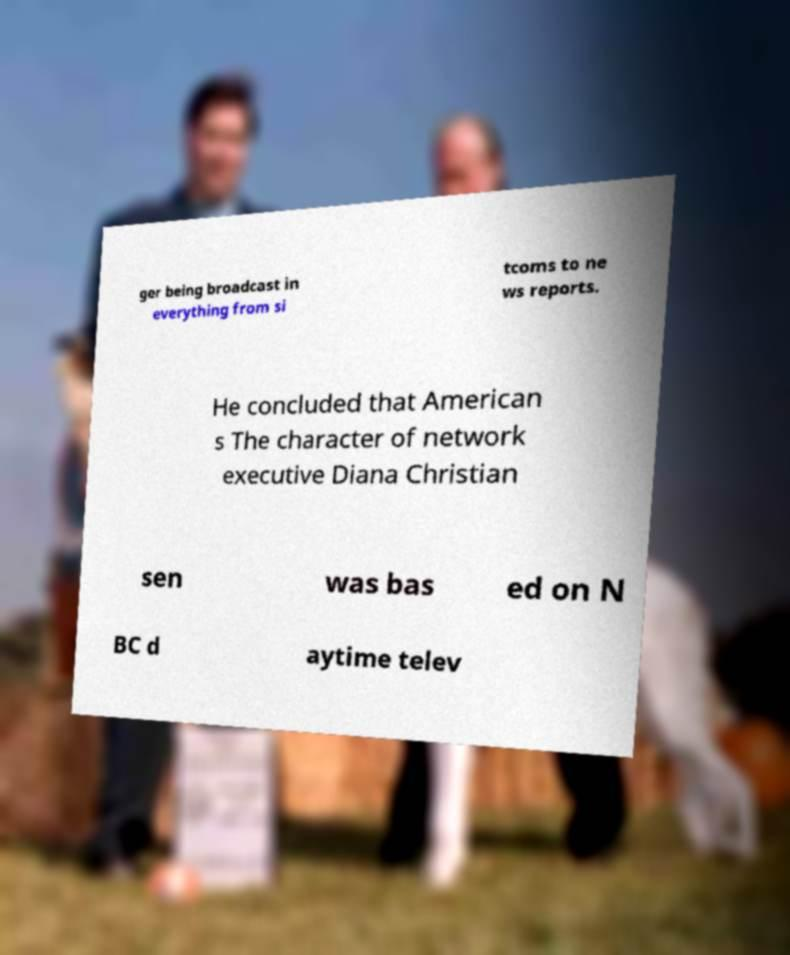I need the written content from this picture converted into text. Can you do that? ger being broadcast in everything from si tcoms to ne ws reports. He concluded that American s The character of network executive Diana Christian sen was bas ed on N BC d aytime telev 